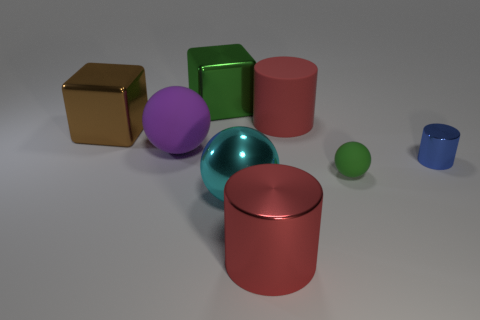Subtract all big metallic spheres. How many spheres are left? 2 Subtract all red cylinders. How many were subtracted if there are1red cylinders left? 1 Subtract 1 cylinders. How many cylinders are left? 2 Subtract all green cylinders. Subtract all blue balls. How many cylinders are left? 3 Subtract all yellow balls. How many brown cubes are left? 1 Subtract all metal cylinders. Subtract all red shiny cylinders. How many objects are left? 5 Add 4 big brown cubes. How many big brown cubes are left? 5 Add 4 big brown balls. How many big brown balls exist? 4 Add 2 big yellow shiny spheres. How many objects exist? 10 Subtract all blue cylinders. How many cylinders are left? 2 